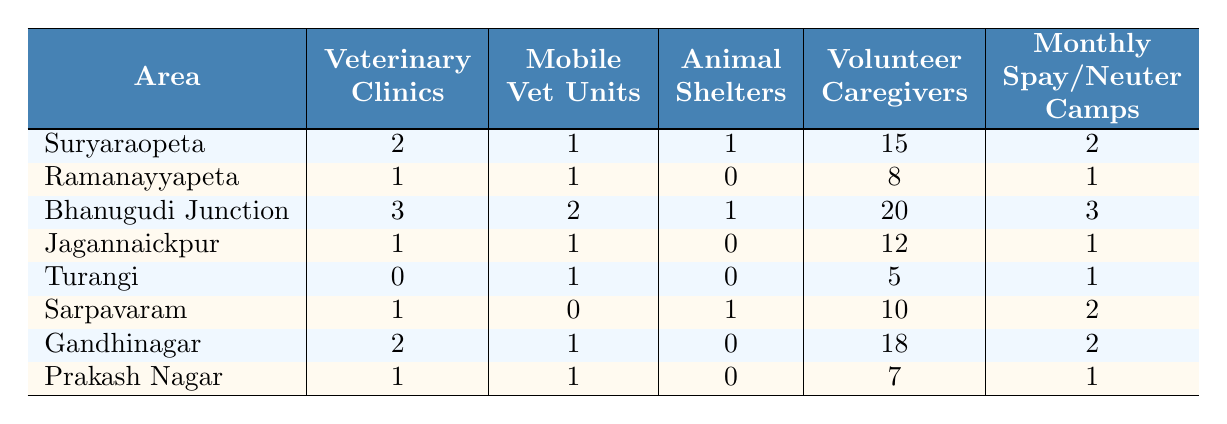What area has the highest number of veterinary clinics? By looking at the table, Bhanugudi Junction has the highest number of veterinary clinics with 3.
Answer: Bhanugudi Junction How many animal shelters are there in Ramanayyapeta? The table shows that there are 0 animal shelters in Ramanayyapeta.
Answer: 0 What is the total number of volunteer caregivers across all areas? Adding the numbers of volunteer caregivers: 15 + 8 + 20 + 12 + 5 + 10 + 18 + 7 = 95.
Answer: 95 Is there an area that has both animal shelters and mobile vet units? Yes, Suryaraopeta and Bhanugudi Junction both have animal shelters and mobile vet units.
Answer: Yes Which area has the lowest number of veterinary clinics? Looking at the table, Turangi and Ramanayyapeta both have the lowest count with 0 and 1 veterinary clinics, respectively, but Turangi has 0.
Answer: Turangi What is the average number of spay/neuter camps per area? Adding the monthly spay/neuter camps: 2 + 1 + 3 + 1 + 1 + 2 + 2 + 1 = 13 camps. There are 8 areas, so the average is 13/8 = 1.625.
Answer: 1.625 In which area do the most volunteer caregivers work, and how many are there? The area with the most volunteer caregivers is Bhanugudi Junction, which has 20 volunteer caregivers.
Answer: Bhanugudi Junction, 20 If we combine the number of veterinary clinics in Suryaraopeta and Gandhinagar, what is the total? Suryaraopeta has 2 veterinary clinics and Gandhinagar has 2 as well, so the total is 2 + 2 = 4.
Answer: 4 Which area has the highest combination of mobile vet units and animal shelters? Bhanugudi Junction has the highest combination with 2 mobile vet units and 1 animal shelter, totaling 3 combined resources.
Answer: Bhanugudi Junction Which area does not have any animal shelters? The areas that do not have any animal shelters are Ramanayyapeta, Jagannaickpur, Turangi, and Gandhinagar.
Answer: Ramanayyapeta, Jagannaickpur, Turangi, Gandhinagar 